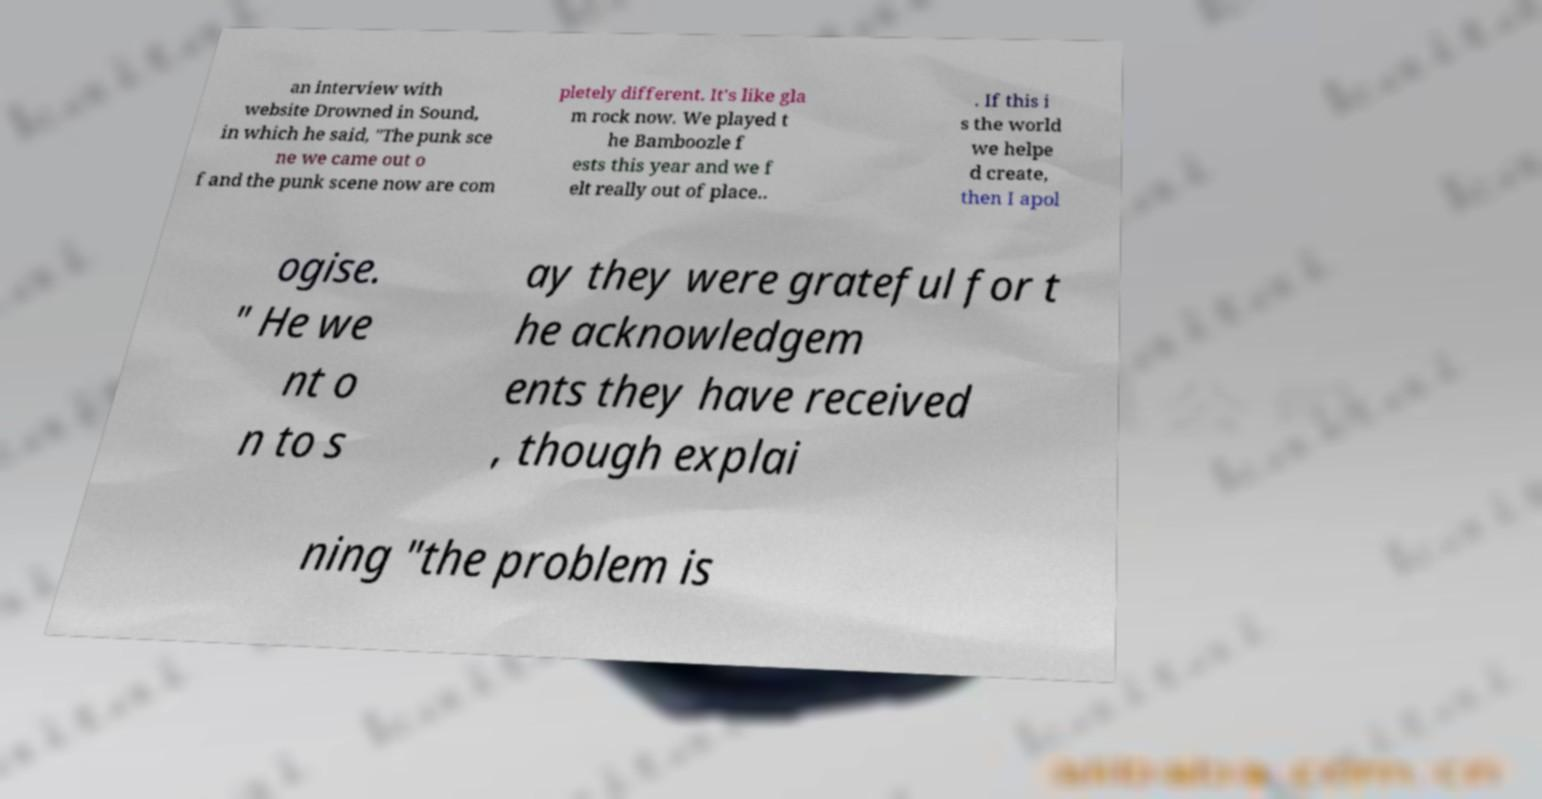What messages or text are displayed in this image? I need them in a readable, typed format. an interview with website Drowned in Sound, in which he said, "The punk sce ne we came out o f and the punk scene now are com pletely different. It's like gla m rock now. We played t he Bamboozle f ests this year and we f elt really out of place.. . If this i s the world we helpe d create, then I apol ogise. " He we nt o n to s ay they were grateful for t he acknowledgem ents they have received , though explai ning "the problem is 